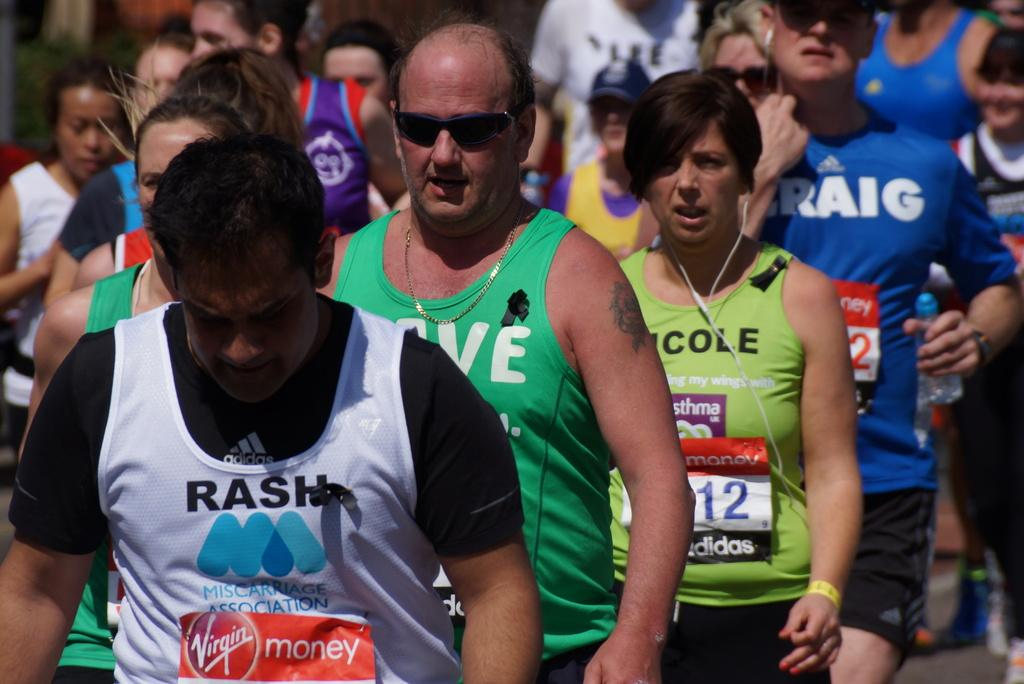What is the main subject of the image? The main subject of the image is a group of people. How are the people arranged in the image? The people are standing in a line. What can be seen on the shirts of the people in the image? Each person has a badge on their shirt. What type of event might be taking place in the image? It appears to be a race or similar event. What type of apparel is the branch wearing in the image? There is no branch or apparel present in the image. What flavor of soda is being served at the event in the image? There is no mention of soda or any food or beverage in the image. 